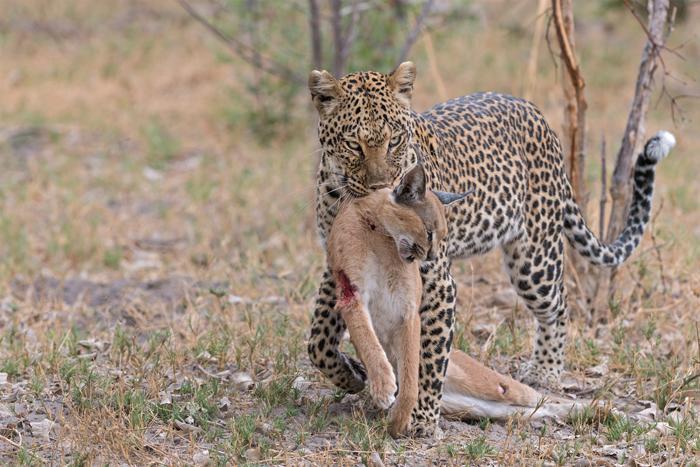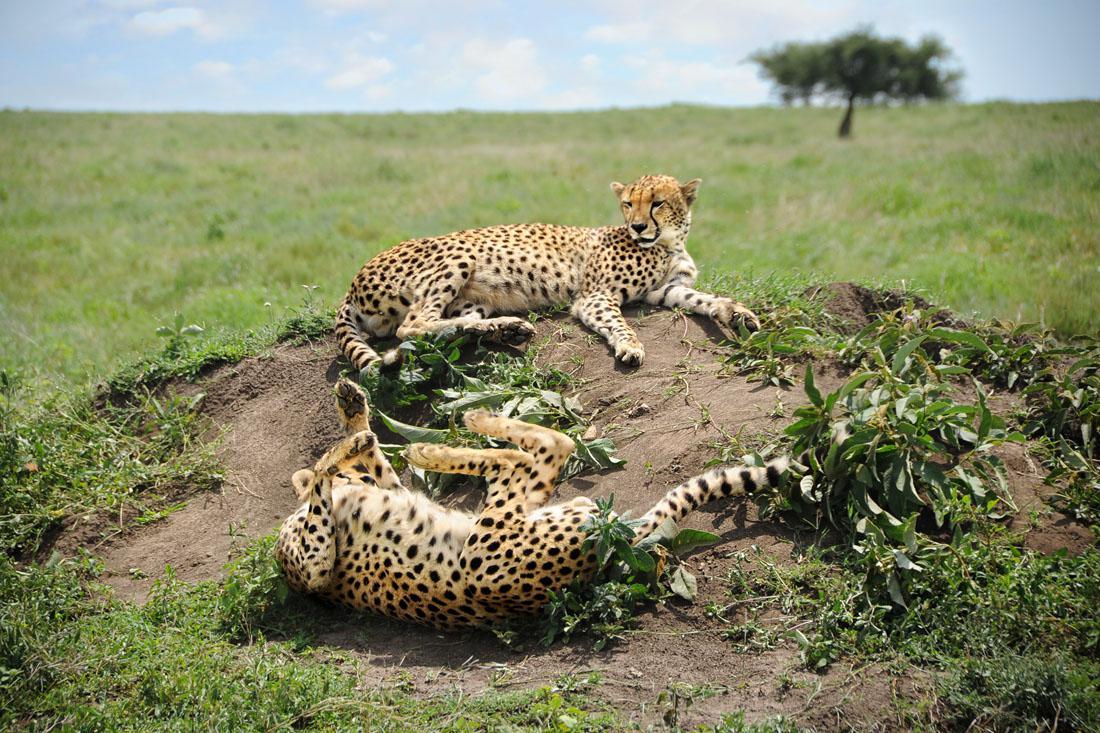The first image is the image on the left, the second image is the image on the right. Given the left and right images, does the statement "There is a cheetah with a dead caracal in one image, and two cheetahs in the other image." hold true? Answer yes or no. Yes. The first image is the image on the left, the second image is the image on the right. For the images displayed, is the sentence "A cheetah is on its back in front of another cheetah who is above it in one image." factually correct? Answer yes or no. Yes. 